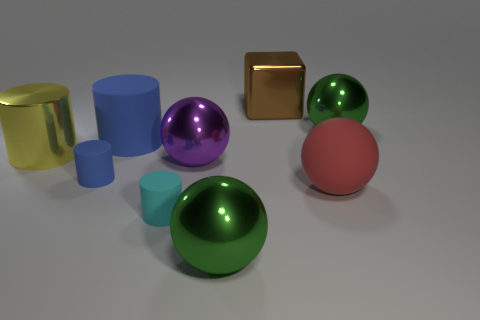Subtract all big shiny cylinders. How many cylinders are left? 3 Subtract 1 blocks. How many blocks are left? 0 Add 1 cyan rubber cylinders. How many objects exist? 10 Subtract all balls. How many objects are left? 5 Add 6 large green balls. How many large green balls exist? 8 Subtract all cyan cylinders. How many cylinders are left? 3 Subtract 1 yellow cylinders. How many objects are left? 8 Subtract all green cylinders. Subtract all blue blocks. How many cylinders are left? 4 Subtract all red cubes. How many yellow cylinders are left? 1 Subtract all cyan cylinders. Subtract all large purple balls. How many objects are left? 7 